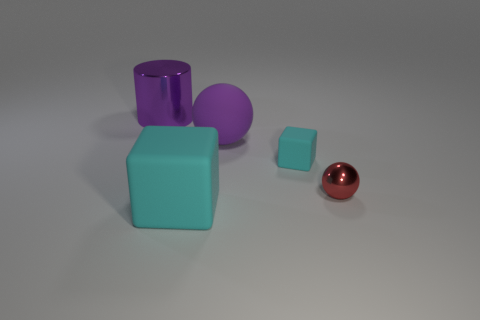How many big cylinders are the same material as the tiny red object?
Provide a short and direct response. 1. Is the material of the large thing that is in front of the tiny red thing the same as the sphere to the left of the tiny cyan matte cube?
Make the answer very short. Yes. What number of big cyan rubber cubes are behind the tiny cube right of the rubber object that is to the left of the big sphere?
Your answer should be very brief. 0. Do the ball in front of the small matte object and the tiny object behind the small red sphere have the same color?
Your response must be concise. No. Is there any other thing of the same color as the shiny cylinder?
Offer a terse response. Yes. There is a big thing that is in front of the purple thing that is in front of the large purple cylinder; what color is it?
Your answer should be compact. Cyan. Are any tiny brown metallic cylinders visible?
Ensure brevity in your answer.  No. What is the color of the thing that is both in front of the tiny cyan rubber block and left of the red metallic thing?
Your response must be concise. Cyan. Is the size of the cyan object that is to the right of the big sphere the same as the metallic object right of the purple metallic object?
Provide a short and direct response. Yes. How many other objects are the same size as the purple shiny object?
Provide a succinct answer. 2. 